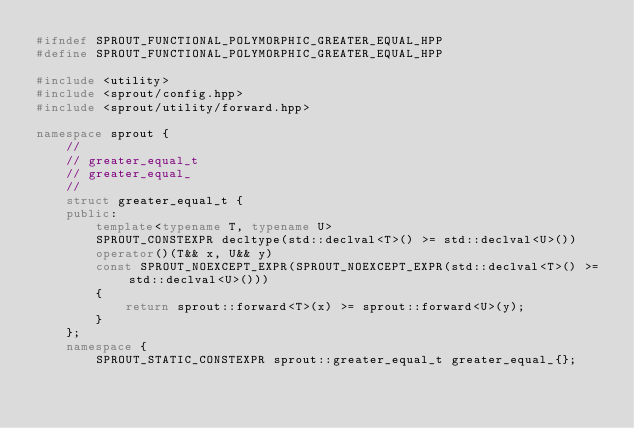Convert code to text. <code><loc_0><loc_0><loc_500><loc_500><_C++_>#ifndef SPROUT_FUNCTIONAL_POLYMORPHIC_GREATER_EQUAL_HPP
#define SPROUT_FUNCTIONAL_POLYMORPHIC_GREATER_EQUAL_HPP

#include <utility>
#include <sprout/config.hpp>
#include <sprout/utility/forward.hpp>

namespace sprout {
	//
	// greater_equal_t
	// greater_equal_
	//
	struct greater_equal_t {
	public:
		template<typename T, typename U>
		SPROUT_CONSTEXPR decltype(std::declval<T>() >= std::declval<U>())
		operator()(T&& x, U&& y)
		const SPROUT_NOEXCEPT_EXPR(SPROUT_NOEXCEPT_EXPR(std::declval<T>() >= std::declval<U>()))
		{
			return sprout::forward<T>(x) >= sprout::forward<U>(y);
		}
	};
	namespace {
		SPROUT_STATIC_CONSTEXPR sprout::greater_equal_t greater_equal_{};</code> 